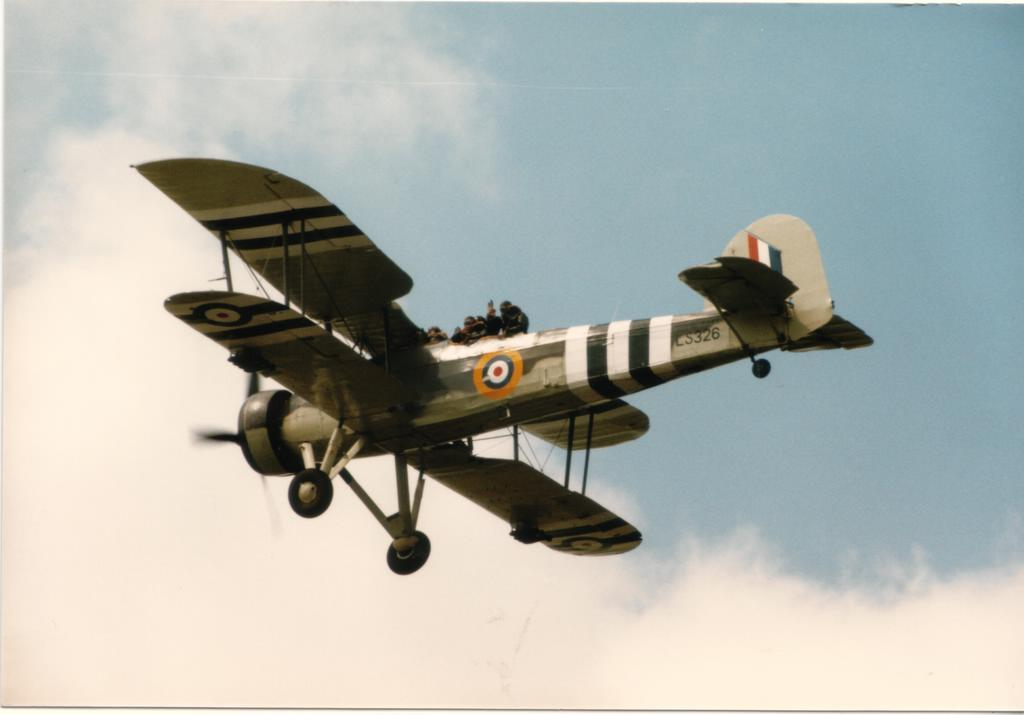What is the main subject of the image? The main subject of the image is a jet plane. What is the jet plane doing in the image? The jet plane is flying in the air. Are there any passengers on the jet plane? Yes, there are people on the jet plane. What can be seen in the background of the image? There are clouds in the sky in the background of the image. What type of gold jewelry is the pilot wearing in the image? There is no pilot or gold jewelry visible in the image. How are the horses reacting to the jet plane in the image? There are no horses present in the image. 